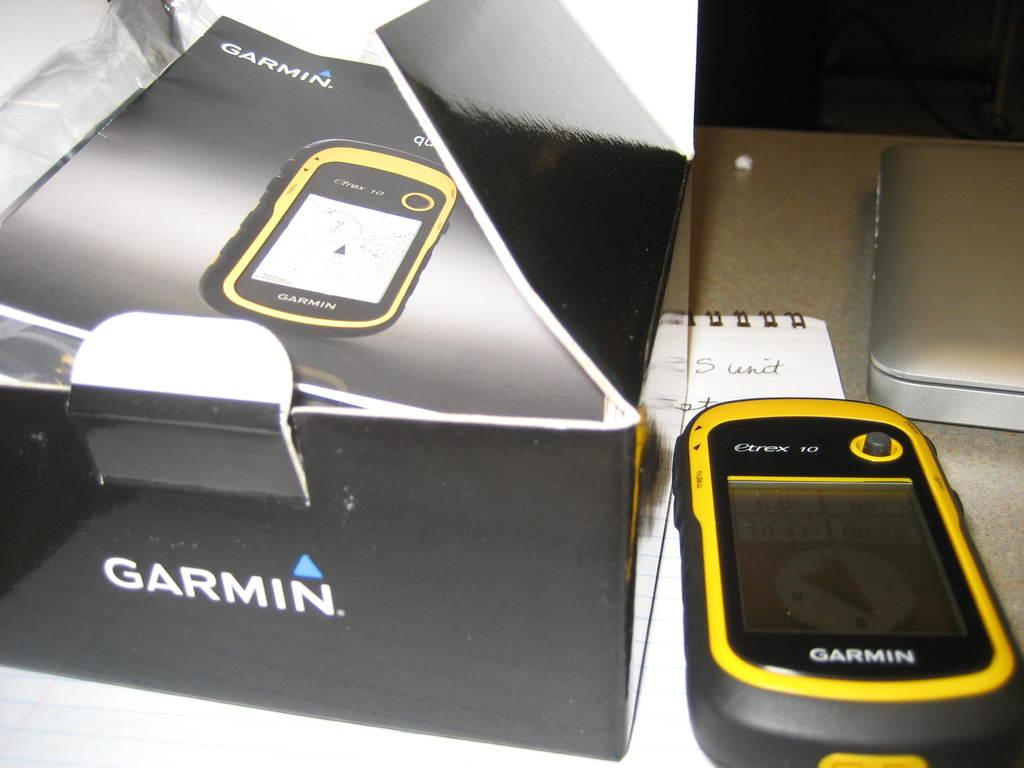Provide a one-sentence caption for the provided image. A Garmin device sits next to its box which has been opened. 